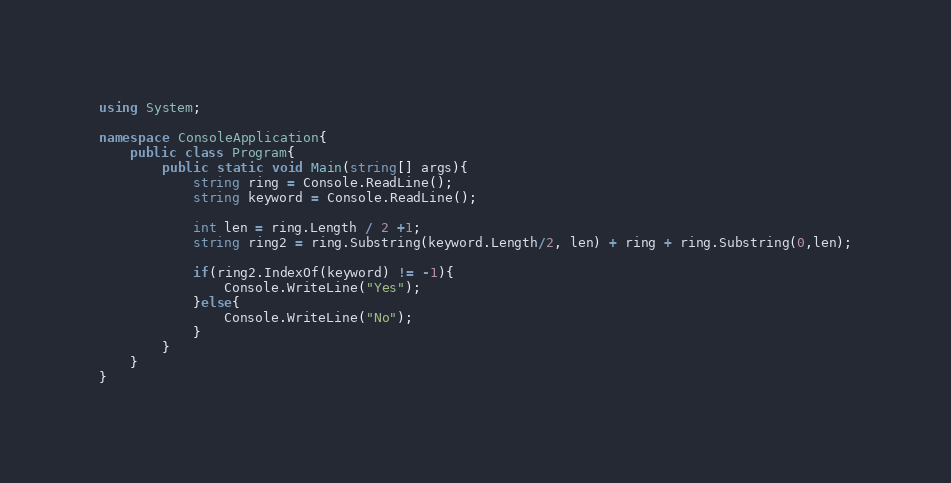Convert code to text. <code><loc_0><loc_0><loc_500><loc_500><_C#_>using System;

namespace ConsoleApplication{
    public class Program{
        public static void Main(string[] args){
            string ring = Console.ReadLine();
            string keyword = Console.ReadLine();

            int len = ring.Length / 2 +1;
            string ring2 = ring.Substring(keyword.Length/2, len) + ring + ring.Substring(0,len);

            if(ring2.IndexOf(keyword) != -1){
                Console.WriteLine("Yes");
            }else{
                Console.WriteLine("No");
            }
        }
    }
}</code> 